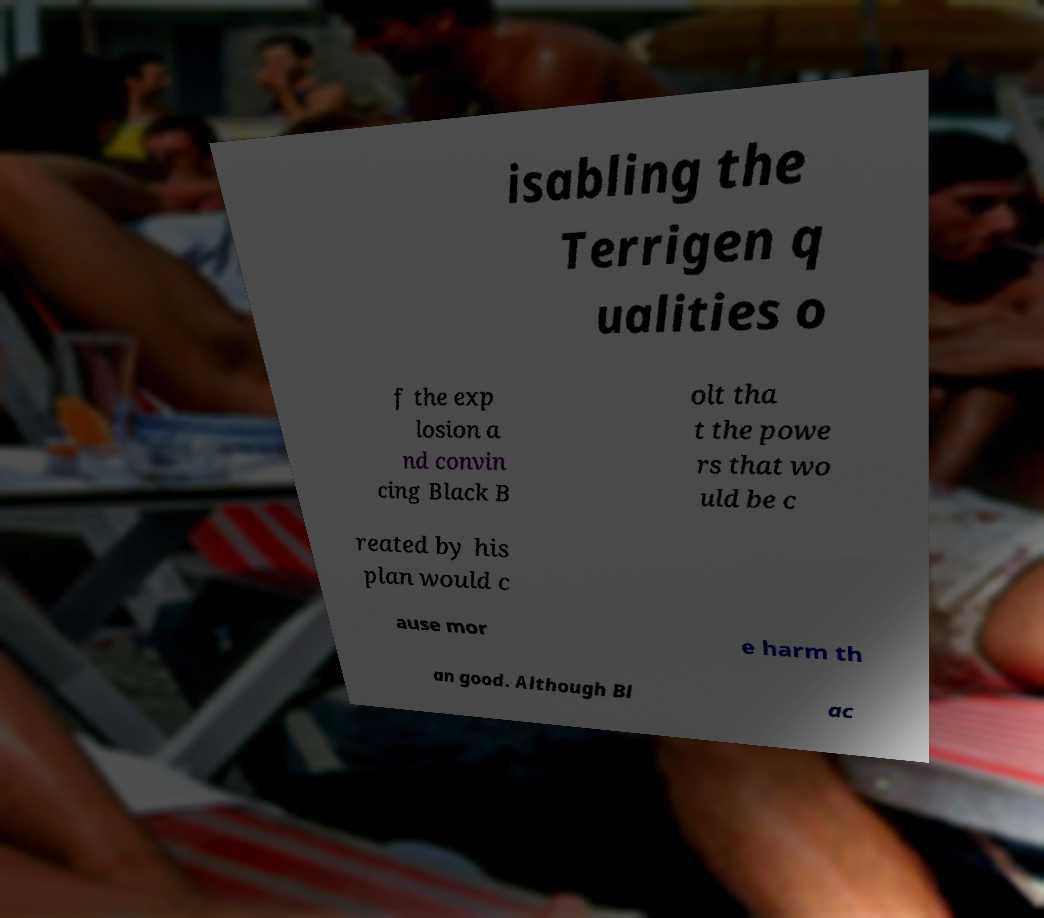Can you read and provide the text displayed in the image?This photo seems to have some interesting text. Can you extract and type it out for me? isabling the Terrigen q ualities o f the exp losion a nd convin cing Black B olt tha t the powe rs that wo uld be c reated by his plan would c ause mor e harm th an good. Although Bl ac 